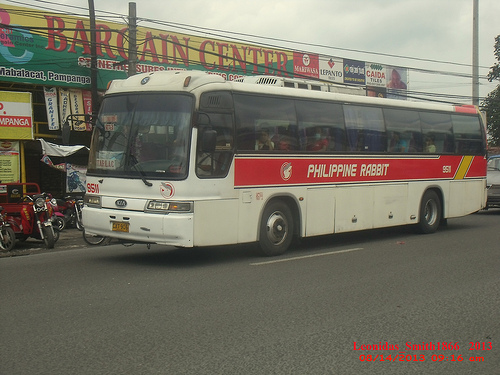<image>
Can you confirm if the bus is behind the pole? No. The bus is not behind the pole. From this viewpoint, the bus appears to be positioned elsewhere in the scene. 